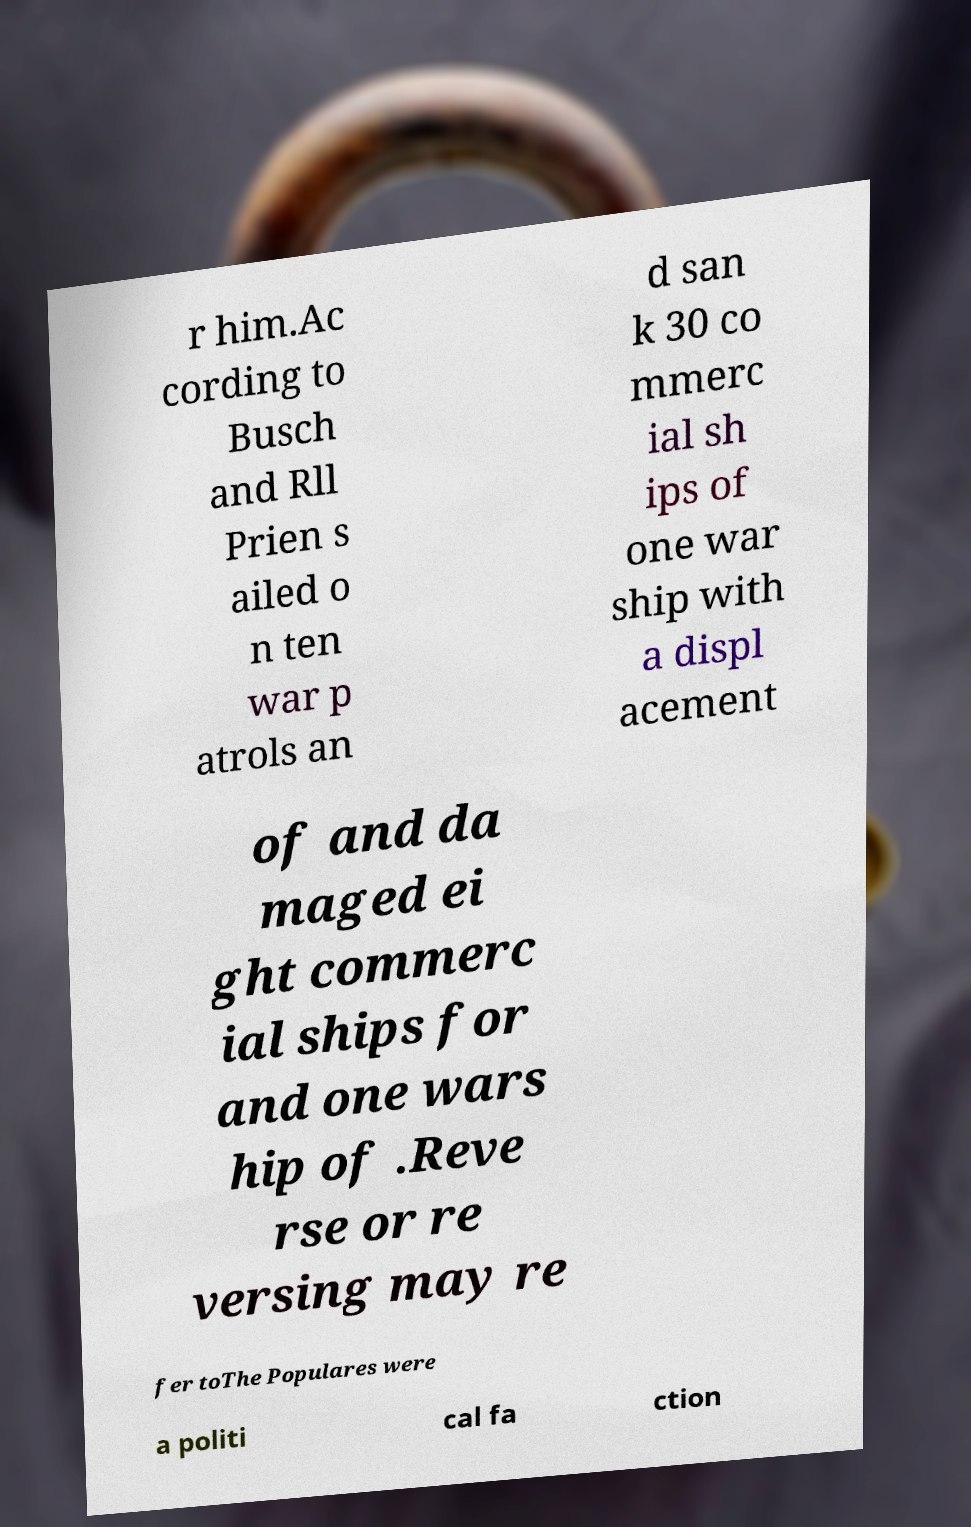Could you extract and type out the text from this image? r him.Ac cording to Busch and Rll Prien s ailed o n ten war p atrols an d san k 30 co mmerc ial sh ips of one war ship with a displ acement of and da maged ei ght commerc ial ships for and one wars hip of .Reve rse or re versing may re fer toThe Populares were a politi cal fa ction 